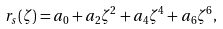<formula> <loc_0><loc_0><loc_500><loc_500>r _ { s } ( \zeta ) = a _ { 0 } + a _ { 2 } \zeta ^ { 2 } + a _ { 4 } \zeta ^ { 4 } + a _ { 6 } \zeta ^ { 6 } ,</formula> 